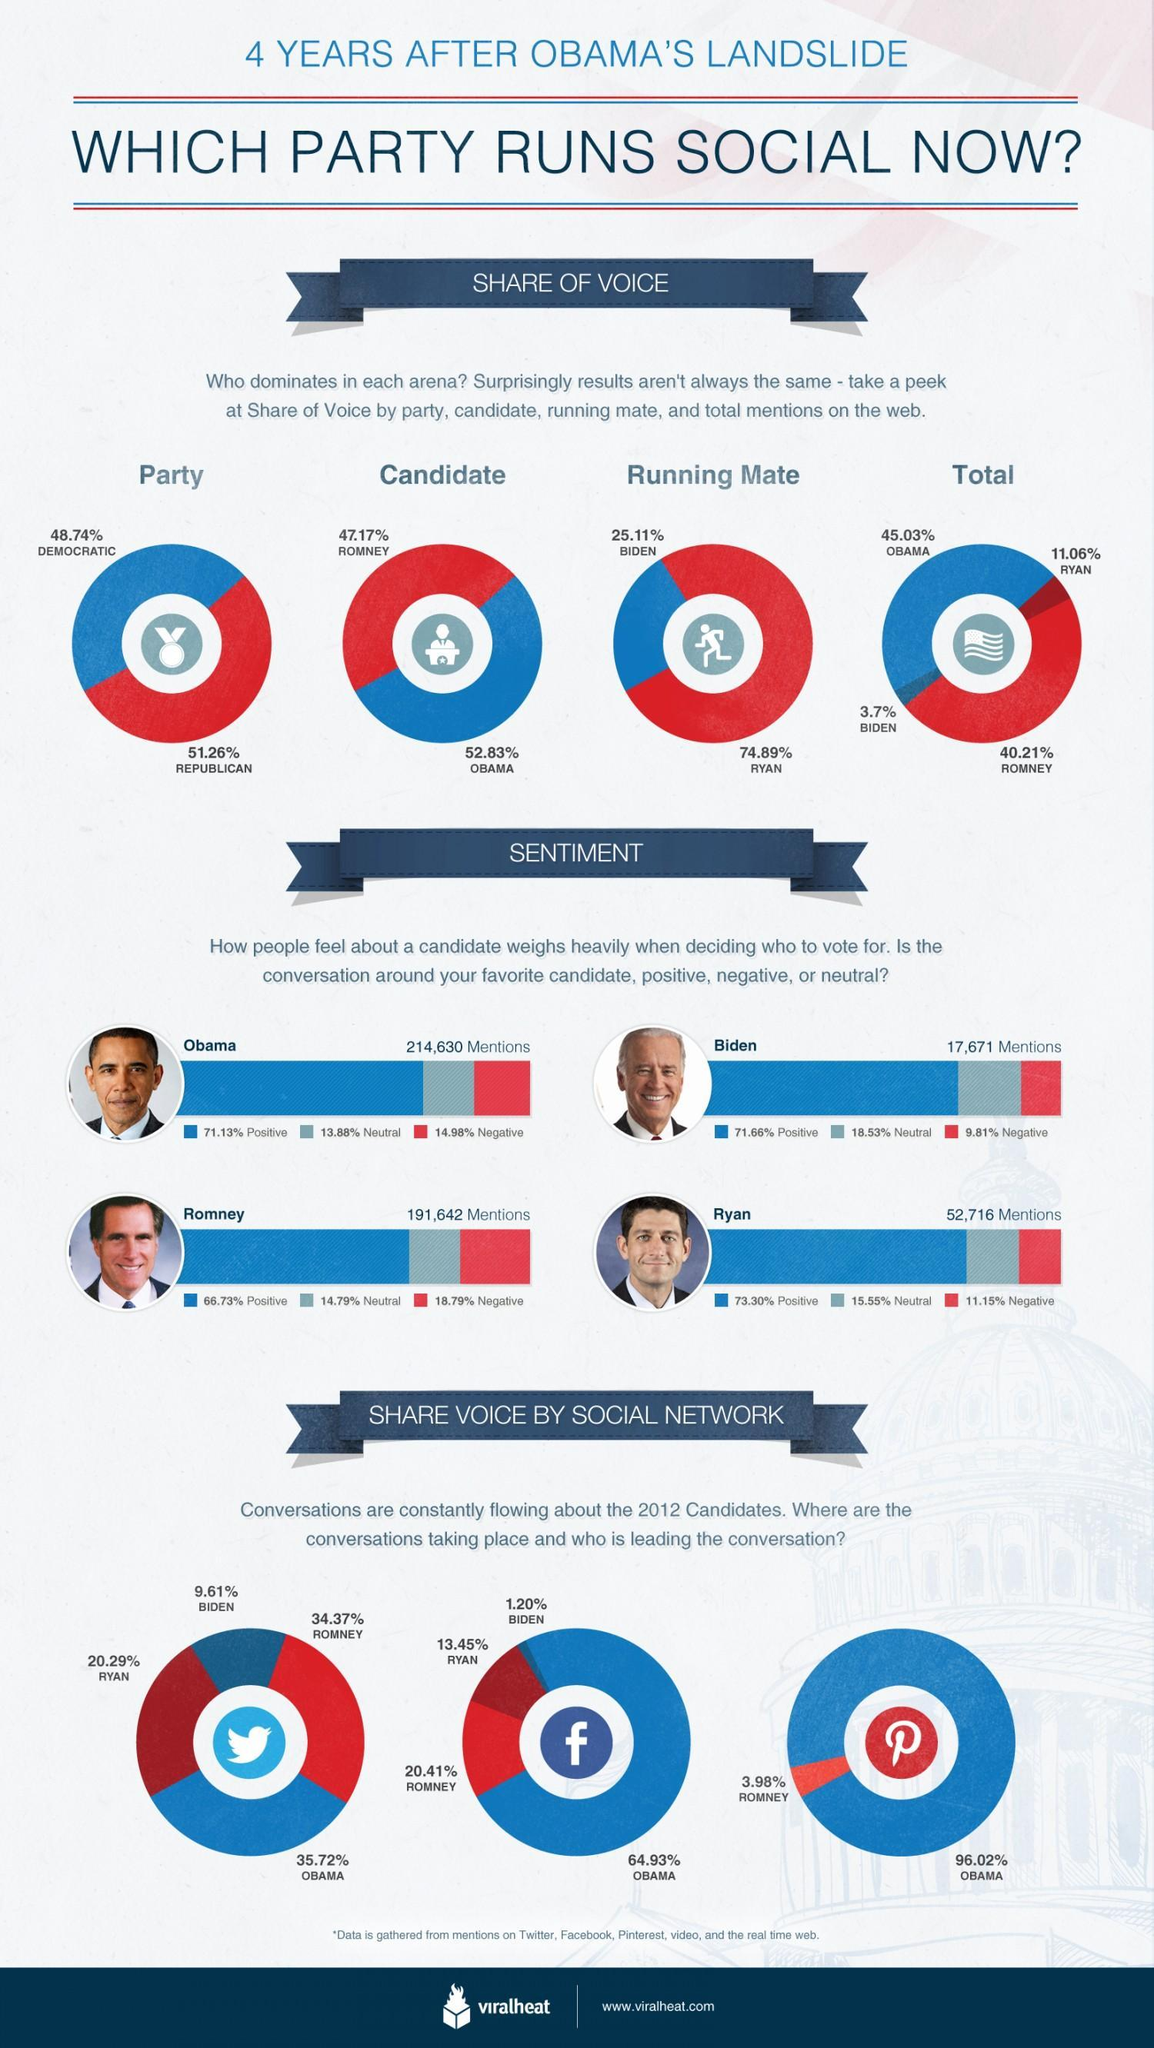Which candidate is more influential on the social media, Romney, Obama, Biden, or Ryan?
Answer the question with a short phrase. Obama Which social media tool had the highest conversations on Obama, Twitter, Facebook, or Pinterest? Pinterest Who is the running mate of Romney ? Ryan Who has had the largest percentage share of positive mentions? Ryan What was the percentage of conversations involving Joe Biden on Facebook? 1.20% Who has had the highest percentage of negative mentions? Romney What percentage of Biden's mentions were neutral, 11.88%, 18.53%, 14.79%, or 15.55%? 18.53% Who has the least percentage of mentions in the Social Media? Biden 